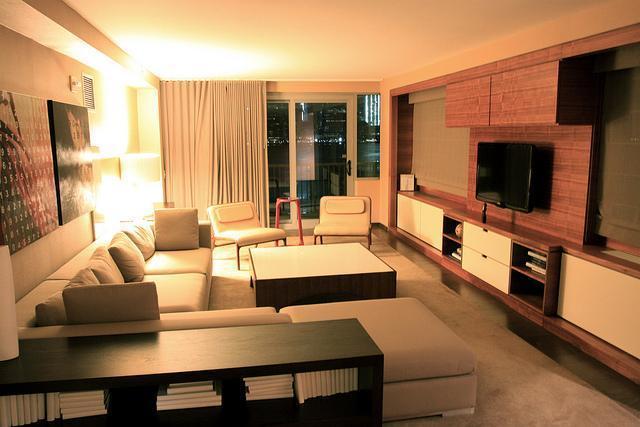How many couches can be seen?
Give a very brief answer. 1. How many books are in the photo?
Give a very brief answer. 2. How many tvs are in the picture?
Give a very brief answer. 1. How many chairs are visible?
Give a very brief answer. 2. 